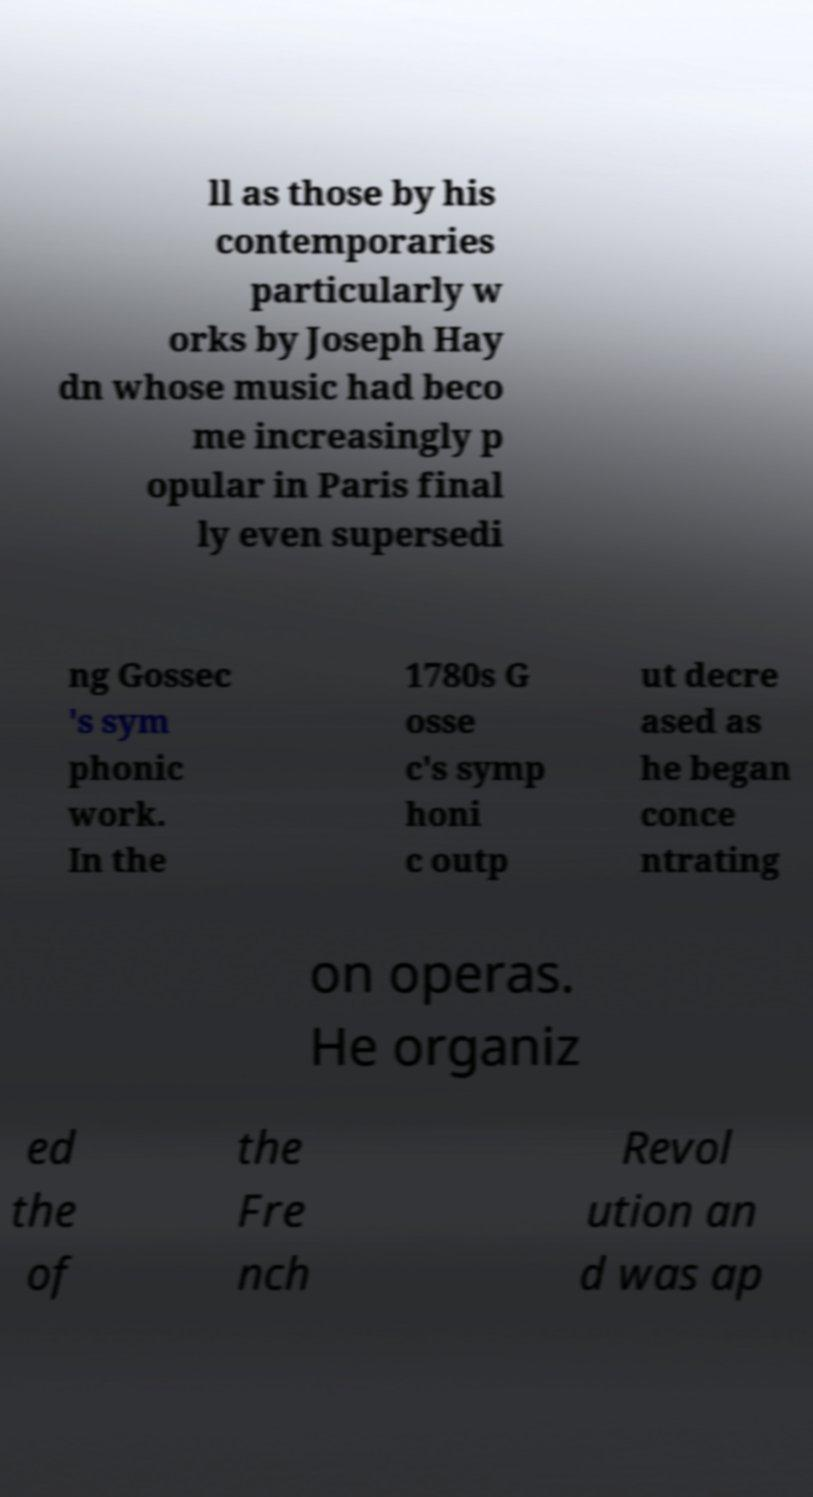I need the written content from this picture converted into text. Can you do that? ll as those by his contemporaries particularly w orks by Joseph Hay dn whose music had beco me increasingly p opular in Paris final ly even supersedi ng Gossec 's sym phonic work. In the 1780s G osse c's symp honi c outp ut decre ased as he began conce ntrating on operas. He organiz ed the of the Fre nch Revol ution an d was ap 